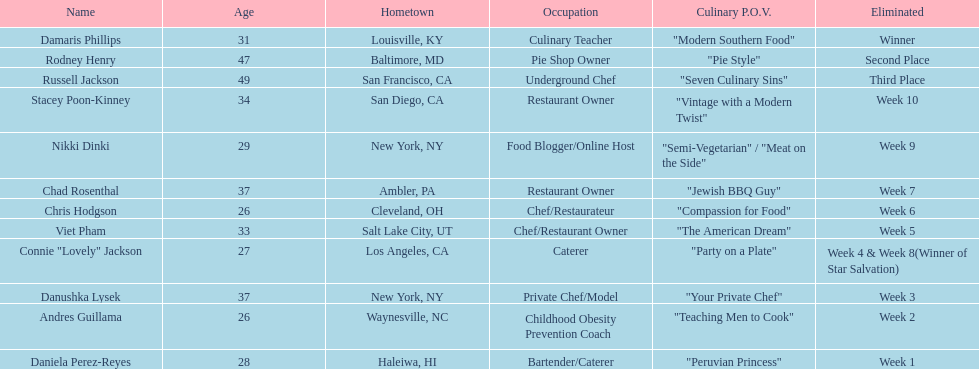Who was the top chef? Damaris Phillips. 